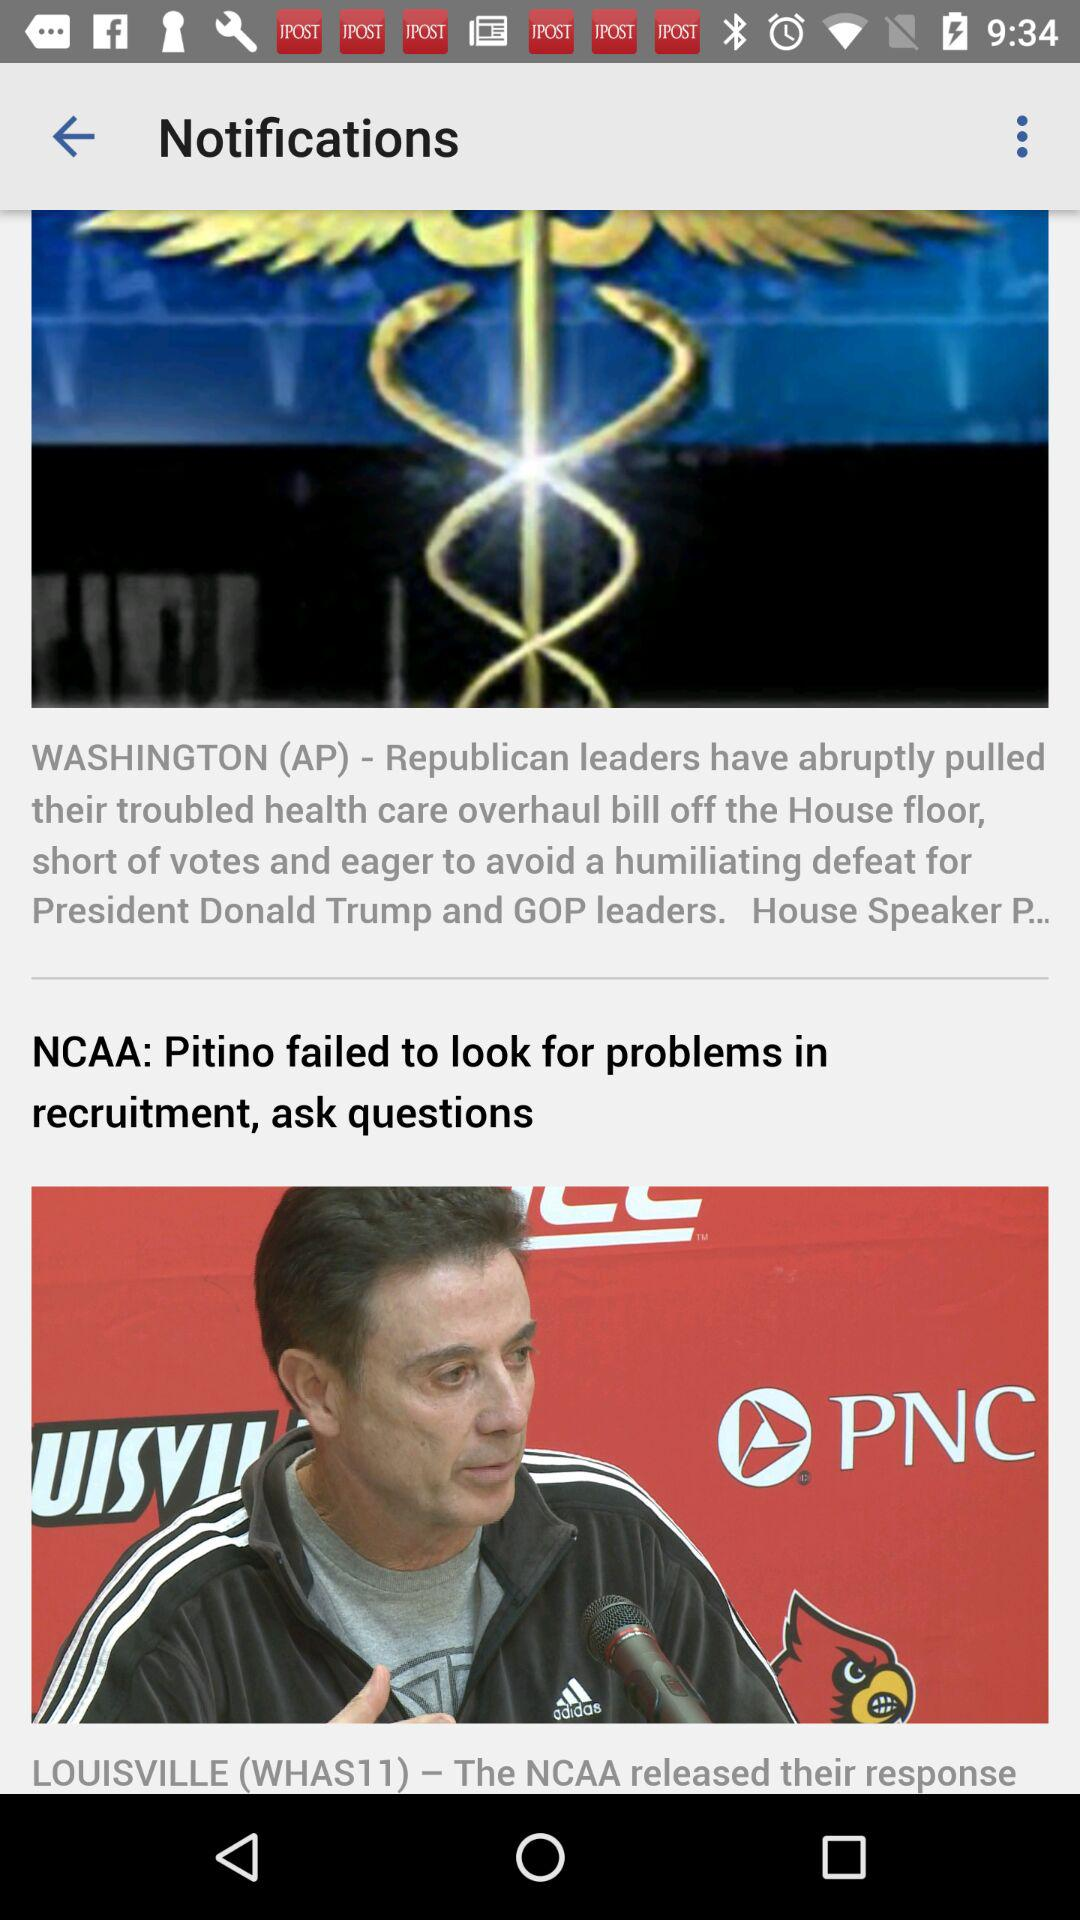Who is the president? The president is Donald Trump. 